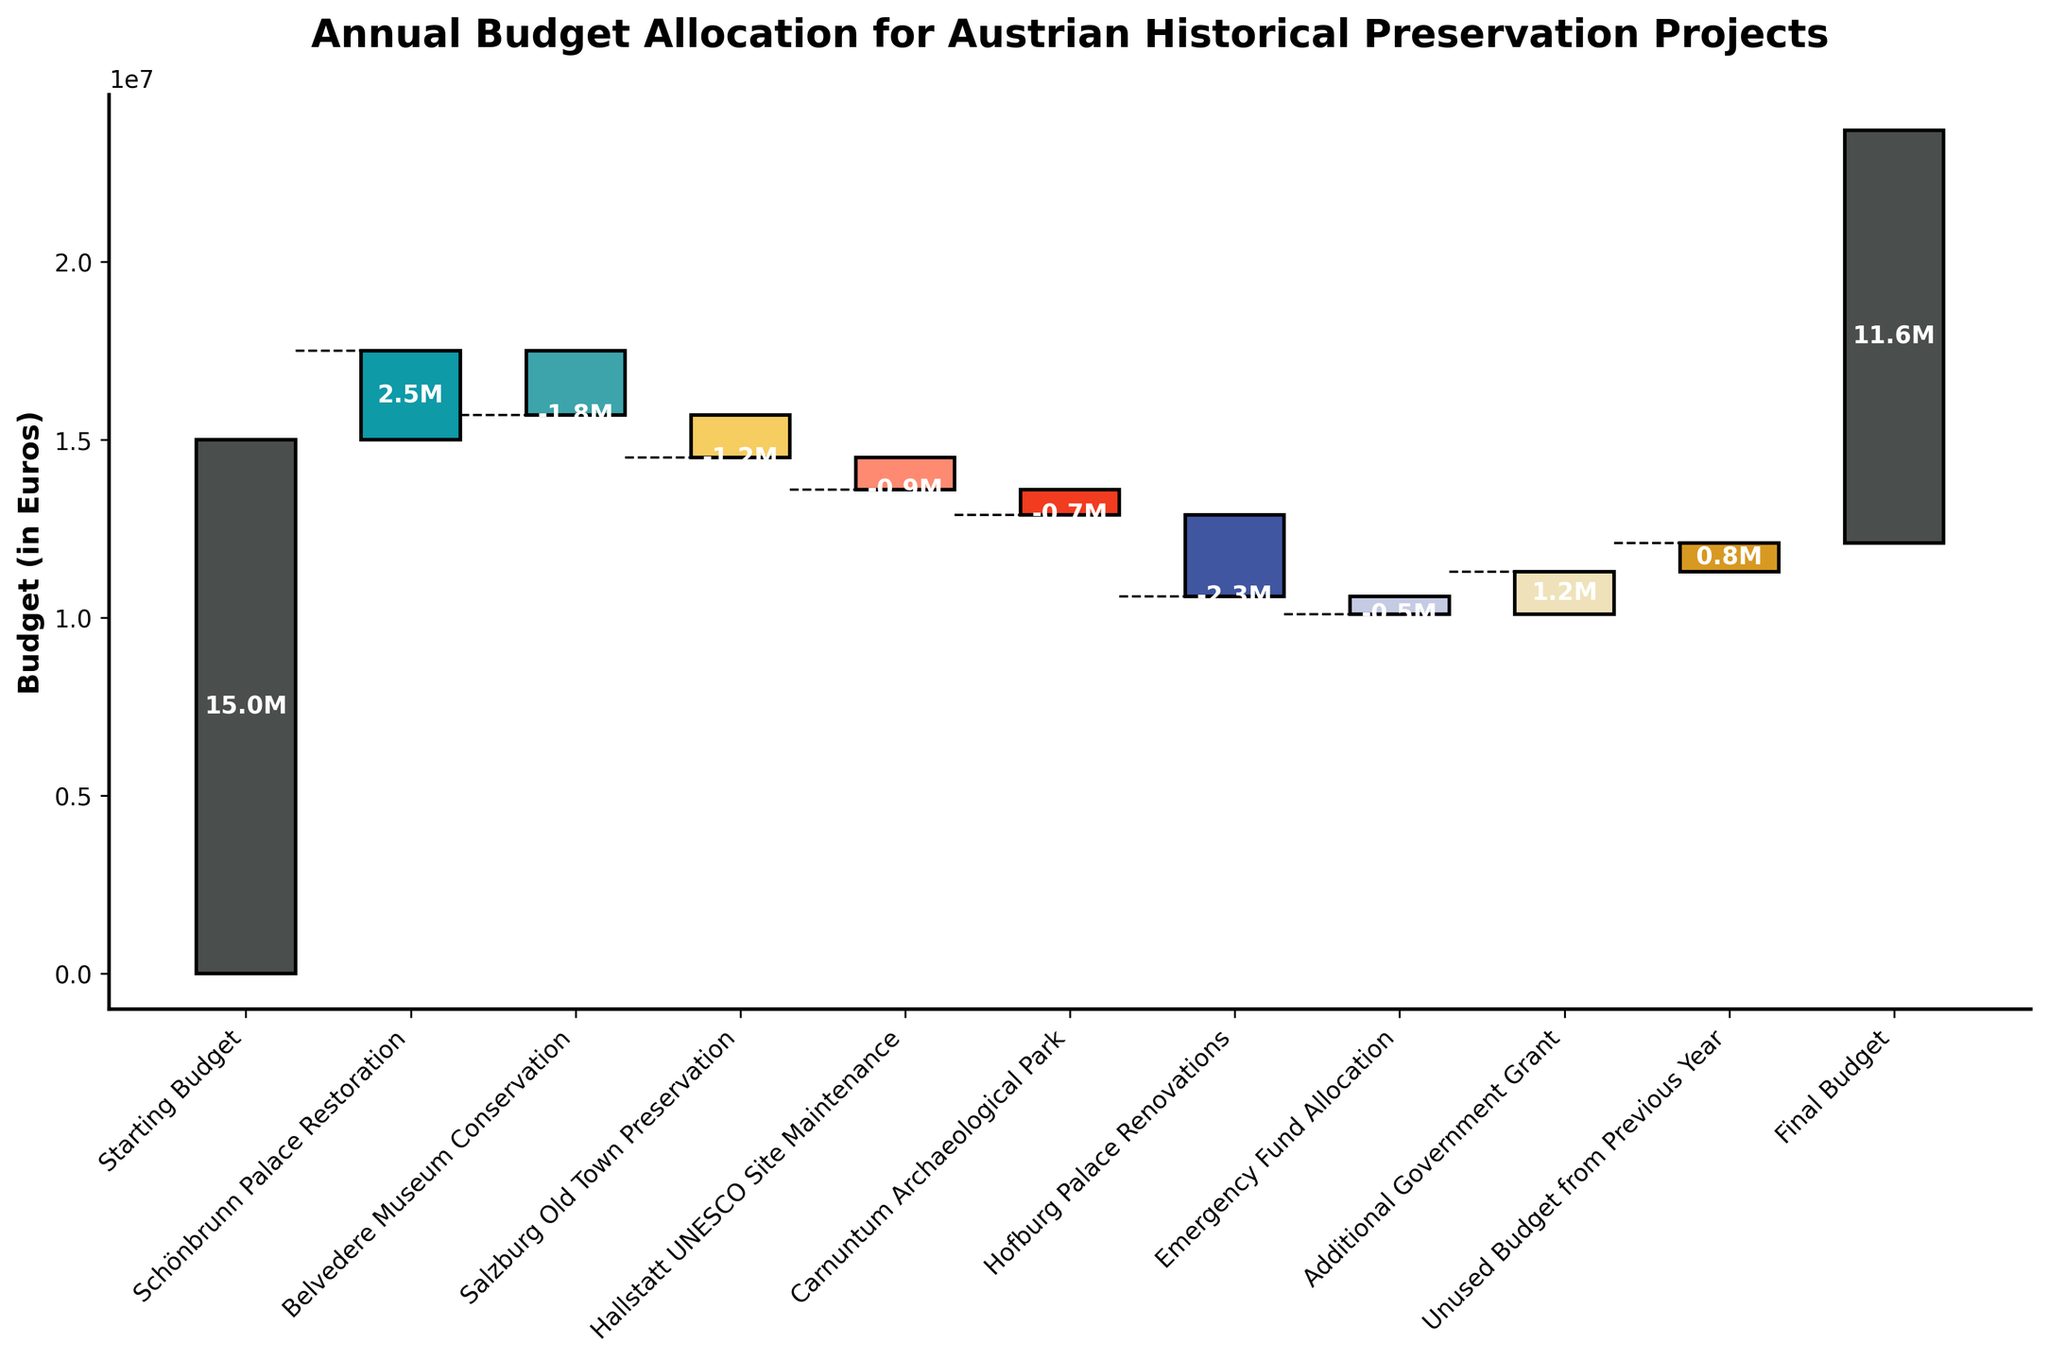What is the title of the chart? The title of the chart is typically located at the top. It is a description of what the chart represents. In this case, the title reads "Annual Budget Allocation for Austrian Historical Preservation Projects".
Answer: Annual Budget Allocation for Austrian Historical Preservation Projects What is the initial budget amount indicated in the chart? The initial budget amount is labeled as "Starting Budget" at the beginning of the Waterfall Chart. The value associated with it is 15,000,000.
Answer: 15,000,000 How much was allocated to the Schönbrunn Palace Restoration? To determine how much was allocated to the Schönbrunn Palace Restoration, look for the corresponding bar labeled with this category. The value shown is 2,500,000.
Answer: 2,500,000 Which project received the highest allocation? By comparing the lengths of the bars representing the various categories, the project with the highest allocation is the one with the longest bar in the positive direction. This is the Schönbrunn Palace Restoration with an allocation of 2,500,000.
Answer: Schönbrunn Palace Restoration How much did the Belvedere Museum Conservation reduce the budget by? The budget reduction for the Belvedere Museum Conservation can be seen by looking at the corresponding bar, which shows a negative value of -1,800,000.
Answer: -1,800,000 What is the cumulative budget after all project allocations and adjustments? The final cumulative budget is indicated by the bar labeled "Final Budget", which shows the value after all additions and subtractions. This final value is 11,600,000.
Answer: 11,600,000 What is the total reduction in the budget due to Hofburg Palace Renovations and Belvedere Museum Conservation combined? To find the combined reduction, sum the negative values of Hofburg Palace Renovations and Belvedere Museum Conservation: -2,300,000 + -1,800,000 = -4,100,000.
Answer: -4,100,000 How does the Emergency Fund Allocation compare to the Additional Government Grant? Compare the lengths of the bars representing these two categories. The Emergency Fund Allocation is -500,000, whereas the Additional Government Grant is 1,200,000, showing that the grant is significantly larger.
Answer: Additional Government Grant is larger What is the net change in the budget after considering both positive allocations and reductions (excluding the starting and final budget)? Calculate the net change by summing all the positive and negative values listed in the data, excluding the Starting and Final Budget. Net change = 2,500,000 + (-1,800,000) + (-1,200,000) + (-900,000) + (-700,000) + (-2,300,000) + (-500,000) + 1,200,000 + 800,000 = -1,900,000.
Answer: -1,900,000 